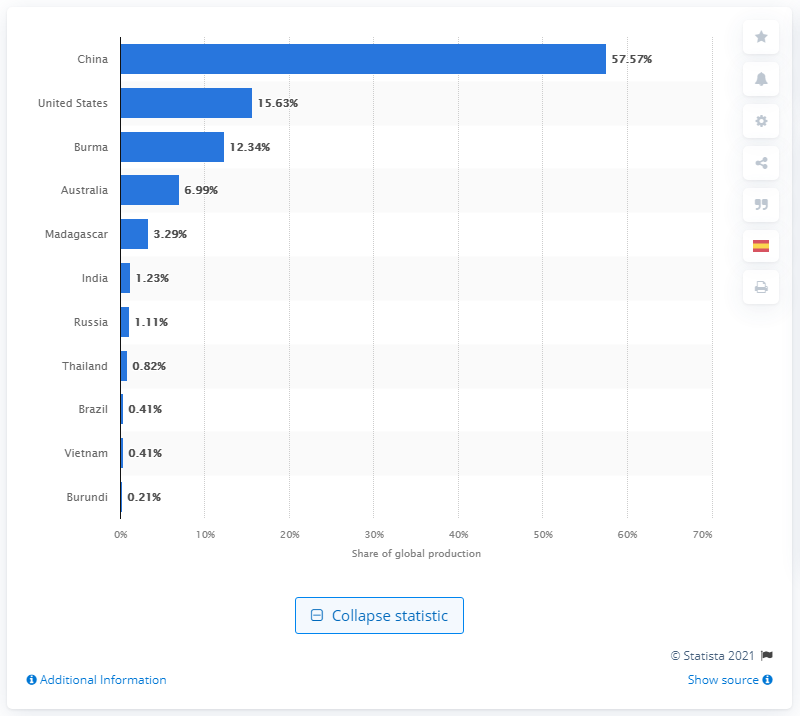Identify some key points in this picture. China is the world's largest producer of rare earth elements. In 2020, China produced 57.57% of the global rare earth mine production. 